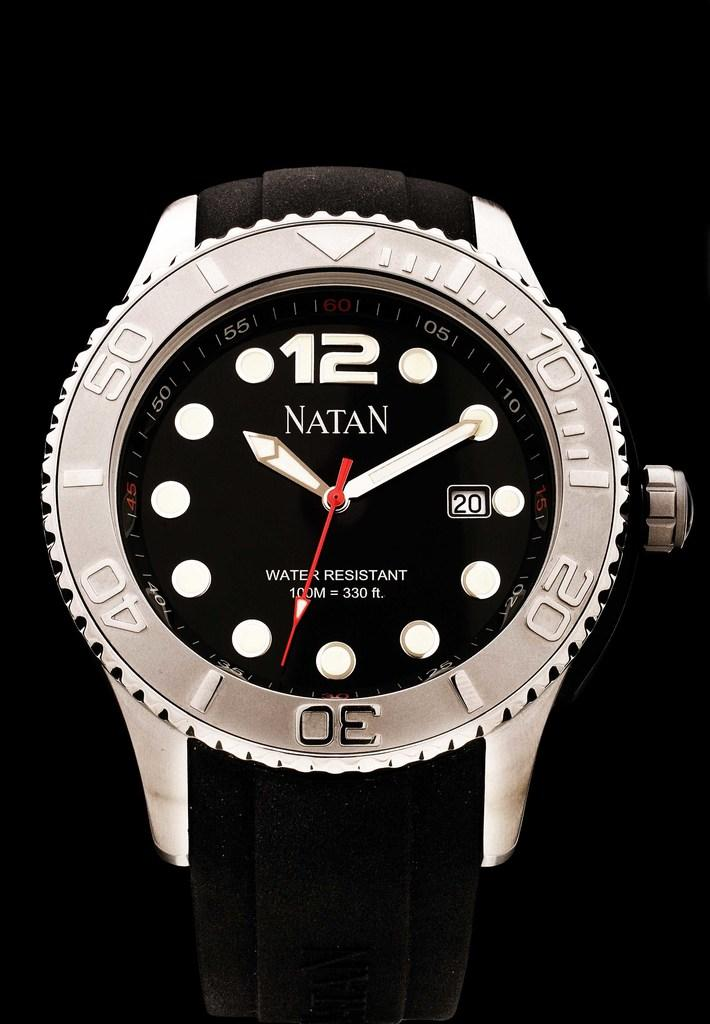What object is the main focus of the image? There is a wrist watch in the image. What is the color of the frame surrounding the wrist watch? The wrist watch has a white frame. Is there any text or name on the wrist watch? Yes, the name "Nathan" is written on the wrist watch. Where is the button located on the wrist watch? There is a button on the left-hand side of the wrist watch. What type of jelly is being used to rub on the wrist watch in the image? There is no jelly or rubbing action present in the image; it only features a wrist watch with a white frame and the name "Nathan" written on it. 